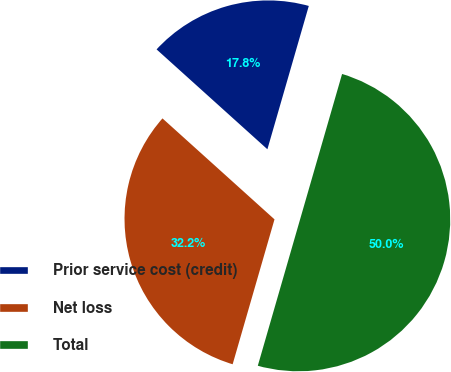Convert chart. <chart><loc_0><loc_0><loc_500><loc_500><pie_chart><fcel>Prior service cost (credit)<fcel>Net loss<fcel>Total<nl><fcel>17.8%<fcel>32.2%<fcel>50.0%<nl></chart> 